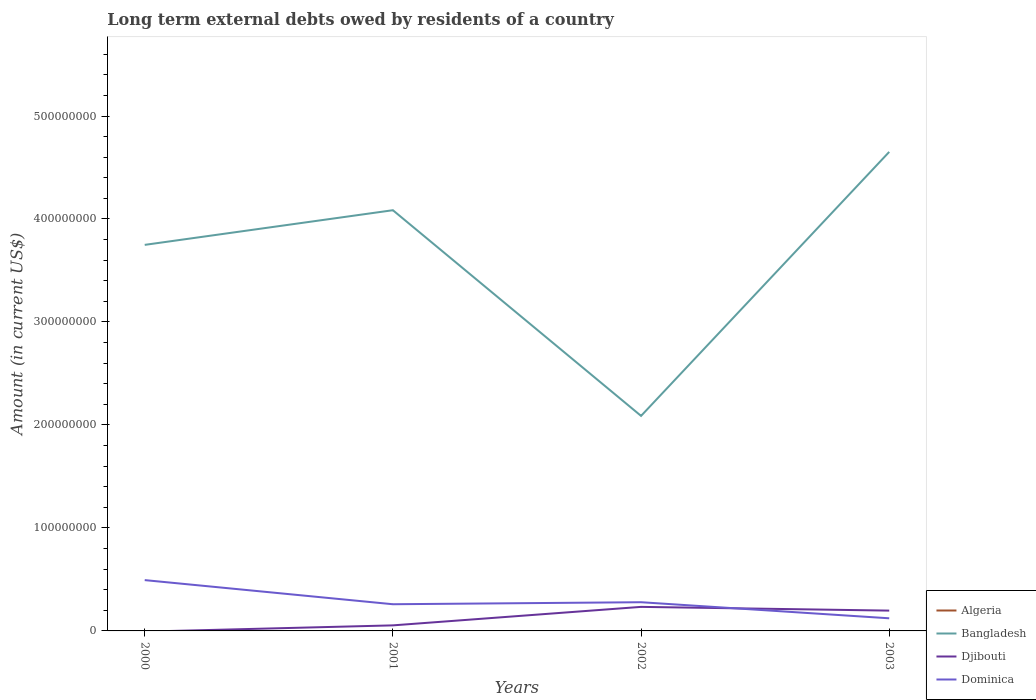Does the line corresponding to Bangladesh intersect with the line corresponding to Djibouti?
Offer a very short reply. No. What is the total amount of long-term external debts owed by residents in Bangladesh in the graph?
Give a very brief answer. -3.36e+07. What is the difference between the highest and the second highest amount of long-term external debts owed by residents in Dominica?
Your response must be concise. 3.71e+07. How many lines are there?
Ensure brevity in your answer.  3. How many years are there in the graph?
Your answer should be compact. 4. What is the difference between two consecutive major ticks on the Y-axis?
Keep it short and to the point. 1.00e+08. Are the values on the major ticks of Y-axis written in scientific E-notation?
Offer a terse response. No. Does the graph contain any zero values?
Make the answer very short. Yes. Does the graph contain grids?
Ensure brevity in your answer.  No. How many legend labels are there?
Your answer should be very brief. 4. What is the title of the graph?
Make the answer very short. Long term external debts owed by residents of a country. Does "Slovak Republic" appear as one of the legend labels in the graph?
Offer a terse response. No. What is the label or title of the Y-axis?
Provide a short and direct response. Amount (in current US$). What is the Amount (in current US$) in Algeria in 2000?
Give a very brief answer. 0. What is the Amount (in current US$) of Bangladesh in 2000?
Offer a terse response. 3.75e+08. What is the Amount (in current US$) of Dominica in 2000?
Keep it short and to the point. 4.93e+07. What is the Amount (in current US$) in Algeria in 2001?
Your response must be concise. 0. What is the Amount (in current US$) of Bangladesh in 2001?
Ensure brevity in your answer.  4.09e+08. What is the Amount (in current US$) in Djibouti in 2001?
Provide a succinct answer. 5.39e+06. What is the Amount (in current US$) of Dominica in 2001?
Provide a short and direct response. 2.59e+07. What is the Amount (in current US$) in Algeria in 2002?
Provide a short and direct response. 0. What is the Amount (in current US$) in Bangladesh in 2002?
Keep it short and to the point. 2.09e+08. What is the Amount (in current US$) in Djibouti in 2002?
Offer a terse response. 2.33e+07. What is the Amount (in current US$) of Dominica in 2002?
Provide a succinct answer. 2.79e+07. What is the Amount (in current US$) of Algeria in 2003?
Ensure brevity in your answer.  0. What is the Amount (in current US$) of Bangladesh in 2003?
Keep it short and to the point. 4.65e+08. What is the Amount (in current US$) of Djibouti in 2003?
Provide a succinct answer. 1.97e+07. What is the Amount (in current US$) of Dominica in 2003?
Ensure brevity in your answer.  1.23e+07. Across all years, what is the maximum Amount (in current US$) of Bangladesh?
Your answer should be very brief. 4.65e+08. Across all years, what is the maximum Amount (in current US$) of Djibouti?
Keep it short and to the point. 2.33e+07. Across all years, what is the maximum Amount (in current US$) in Dominica?
Your answer should be very brief. 4.93e+07. Across all years, what is the minimum Amount (in current US$) of Bangladesh?
Make the answer very short. 2.09e+08. Across all years, what is the minimum Amount (in current US$) in Djibouti?
Provide a short and direct response. 0. Across all years, what is the minimum Amount (in current US$) of Dominica?
Your answer should be compact. 1.23e+07. What is the total Amount (in current US$) in Algeria in the graph?
Your answer should be compact. 0. What is the total Amount (in current US$) of Bangladesh in the graph?
Provide a succinct answer. 1.46e+09. What is the total Amount (in current US$) in Djibouti in the graph?
Give a very brief answer. 4.85e+07. What is the total Amount (in current US$) in Dominica in the graph?
Your answer should be compact. 1.15e+08. What is the difference between the Amount (in current US$) in Bangladesh in 2000 and that in 2001?
Your answer should be compact. -3.36e+07. What is the difference between the Amount (in current US$) in Dominica in 2000 and that in 2001?
Offer a very short reply. 2.34e+07. What is the difference between the Amount (in current US$) of Bangladesh in 2000 and that in 2002?
Keep it short and to the point. 1.66e+08. What is the difference between the Amount (in current US$) of Dominica in 2000 and that in 2002?
Your response must be concise. 2.15e+07. What is the difference between the Amount (in current US$) of Bangladesh in 2000 and that in 2003?
Offer a very short reply. -9.03e+07. What is the difference between the Amount (in current US$) in Dominica in 2000 and that in 2003?
Make the answer very short. 3.71e+07. What is the difference between the Amount (in current US$) in Bangladesh in 2001 and that in 2002?
Provide a short and direct response. 2.00e+08. What is the difference between the Amount (in current US$) of Djibouti in 2001 and that in 2002?
Offer a terse response. -1.80e+07. What is the difference between the Amount (in current US$) in Dominica in 2001 and that in 2002?
Your answer should be compact. -1.96e+06. What is the difference between the Amount (in current US$) in Bangladesh in 2001 and that in 2003?
Provide a short and direct response. -5.66e+07. What is the difference between the Amount (in current US$) in Djibouti in 2001 and that in 2003?
Your answer should be compact. -1.43e+07. What is the difference between the Amount (in current US$) in Dominica in 2001 and that in 2003?
Provide a succinct answer. 1.36e+07. What is the difference between the Amount (in current US$) of Bangladesh in 2002 and that in 2003?
Offer a terse response. -2.56e+08. What is the difference between the Amount (in current US$) of Djibouti in 2002 and that in 2003?
Offer a very short reply. 3.62e+06. What is the difference between the Amount (in current US$) of Dominica in 2002 and that in 2003?
Make the answer very short. 1.56e+07. What is the difference between the Amount (in current US$) of Bangladesh in 2000 and the Amount (in current US$) of Djibouti in 2001?
Make the answer very short. 3.69e+08. What is the difference between the Amount (in current US$) of Bangladesh in 2000 and the Amount (in current US$) of Dominica in 2001?
Ensure brevity in your answer.  3.49e+08. What is the difference between the Amount (in current US$) of Bangladesh in 2000 and the Amount (in current US$) of Djibouti in 2002?
Make the answer very short. 3.52e+08. What is the difference between the Amount (in current US$) of Bangladesh in 2000 and the Amount (in current US$) of Dominica in 2002?
Offer a terse response. 3.47e+08. What is the difference between the Amount (in current US$) in Bangladesh in 2000 and the Amount (in current US$) in Djibouti in 2003?
Your answer should be very brief. 3.55e+08. What is the difference between the Amount (in current US$) of Bangladesh in 2000 and the Amount (in current US$) of Dominica in 2003?
Your answer should be compact. 3.63e+08. What is the difference between the Amount (in current US$) of Bangladesh in 2001 and the Amount (in current US$) of Djibouti in 2002?
Your answer should be very brief. 3.85e+08. What is the difference between the Amount (in current US$) of Bangladesh in 2001 and the Amount (in current US$) of Dominica in 2002?
Offer a terse response. 3.81e+08. What is the difference between the Amount (in current US$) in Djibouti in 2001 and the Amount (in current US$) in Dominica in 2002?
Your answer should be compact. -2.25e+07. What is the difference between the Amount (in current US$) of Bangladesh in 2001 and the Amount (in current US$) of Djibouti in 2003?
Keep it short and to the point. 3.89e+08. What is the difference between the Amount (in current US$) in Bangladesh in 2001 and the Amount (in current US$) in Dominica in 2003?
Provide a succinct answer. 3.96e+08. What is the difference between the Amount (in current US$) of Djibouti in 2001 and the Amount (in current US$) of Dominica in 2003?
Your response must be concise. -6.87e+06. What is the difference between the Amount (in current US$) in Bangladesh in 2002 and the Amount (in current US$) in Djibouti in 2003?
Your answer should be compact. 1.89e+08. What is the difference between the Amount (in current US$) of Bangladesh in 2002 and the Amount (in current US$) of Dominica in 2003?
Provide a short and direct response. 1.97e+08. What is the difference between the Amount (in current US$) in Djibouti in 2002 and the Amount (in current US$) in Dominica in 2003?
Offer a terse response. 1.11e+07. What is the average Amount (in current US$) of Algeria per year?
Your response must be concise. 0. What is the average Amount (in current US$) of Bangladesh per year?
Your answer should be very brief. 3.64e+08. What is the average Amount (in current US$) in Djibouti per year?
Your response must be concise. 1.21e+07. What is the average Amount (in current US$) of Dominica per year?
Ensure brevity in your answer.  2.88e+07. In the year 2000, what is the difference between the Amount (in current US$) of Bangladesh and Amount (in current US$) of Dominica?
Your answer should be compact. 3.26e+08. In the year 2001, what is the difference between the Amount (in current US$) in Bangladesh and Amount (in current US$) in Djibouti?
Offer a terse response. 4.03e+08. In the year 2001, what is the difference between the Amount (in current US$) of Bangladesh and Amount (in current US$) of Dominica?
Offer a very short reply. 3.83e+08. In the year 2001, what is the difference between the Amount (in current US$) of Djibouti and Amount (in current US$) of Dominica?
Keep it short and to the point. -2.05e+07. In the year 2002, what is the difference between the Amount (in current US$) in Bangladesh and Amount (in current US$) in Djibouti?
Make the answer very short. 1.85e+08. In the year 2002, what is the difference between the Amount (in current US$) of Bangladesh and Amount (in current US$) of Dominica?
Keep it short and to the point. 1.81e+08. In the year 2002, what is the difference between the Amount (in current US$) of Djibouti and Amount (in current US$) of Dominica?
Provide a succinct answer. -4.52e+06. In the year 2003, what is the difference between the Amount (in current US$) in Bangladesh and Amount (in current US$) in Djibouti?
Ensure brevity in your answer.  4.45e+08. In the year 2003, what is the difference between the Amount (in current US$) of Bangladesh and Amount (in current US$) of Dominica?
Make the answer very short. 4.53e+08. In the year 2003, what is the difference between the Amount (in current US$) of Djibouti and Amount (in current US$) of Dominica?
Make the answer very short. 7.47e+06. What is the ratio of the Amount (in current US$) in Bangladesh in 2000 to that in 2001?
Offer a very short reply. 0.92. What is the ratio of the Amount (in current US$) in Dominica in 2000 to that in 2001?
Offer a terse response. 1.9. What is the ratio of the Amount (in current US$) of Bangladesh in 2000 to that in 2002?
Provide a short and direct response. 1.8. What is the ratio of the Amount (in current US$) of Dominica in 2000 to that in 2002?
Make the answer very short. 1.77. What is the ratio of the Amount (in current US$) of Bangladesh in 2000 to that in 2003?
Your answer should be very brief. 0.81. What is the ratio of the Amount (in current US$) of Dominica in 2000 to that in 2003?
Provide a short and direct response. 4.02. What is the ratio of the Amount (in current US$) of Bangladesh in 2001 to that in 2002?
Provide a succinct answer. 1.96. What is the ratio of the Amount (in current US$) in Djibouti in 2001 to that in 2002?
Give a very brief answer. 0.23. What is the ratio of the Amount (in current US$) of Dominica in 2001 to that in 2002?
Provide a short and direct response. 0.93. What is the ratio of the Amount (in current US$) in Bangladesh in 2001 to that in 2003?
Offer a terse response. 0.88. What is the ratio of the Amount (in current US$) of Djibouti in 2001 to that in 2003?
Your response must be concise. 0.27. What is the ratio of the Amount (in current US$) of Dominica in 2001 to that in 2003?
Offer a very short reply. 2.11. What is the ratio of the Amount (in current US$) in Bangladesh in 2002 to that in 2003?
Your response must be concise. 0.45. What is the ratio of the Amount (in current US$) of Djibouti in 2002 to that in 2003?
Offer a terse response. 1.18. What is the ratio of the Amount (in current US$) of Dominica in 2002 to that in 2003?
Make the answer very short. 2.27. What is the difference between the highest and the second highest Amount (in current US$) in Bangladesh?
Your response must be concise. 5.66e+07. What is the difference between the highest and the second highest Amount (in current US$) of Djibouti?
Provide a short and direct response. 3.62e+06. What is the difference between the highest and the second highest Amount (in current US$) in Dominica?
Give a very brief answer. 2.15e+07. What is the difference between the highest and the lowest Amount (in current US$) in Bangladesh?
Offer a terse response. 2.56e+08. What is the difference between the highest and the lowest Amount (in current US$) in Djibouti?
Ensure brevity in your answer.  2.33e+07. What is the difference between the highest and the lowest Amount (in current US$) of Dominica?
Offer a very short reply. 3.71e+07. 